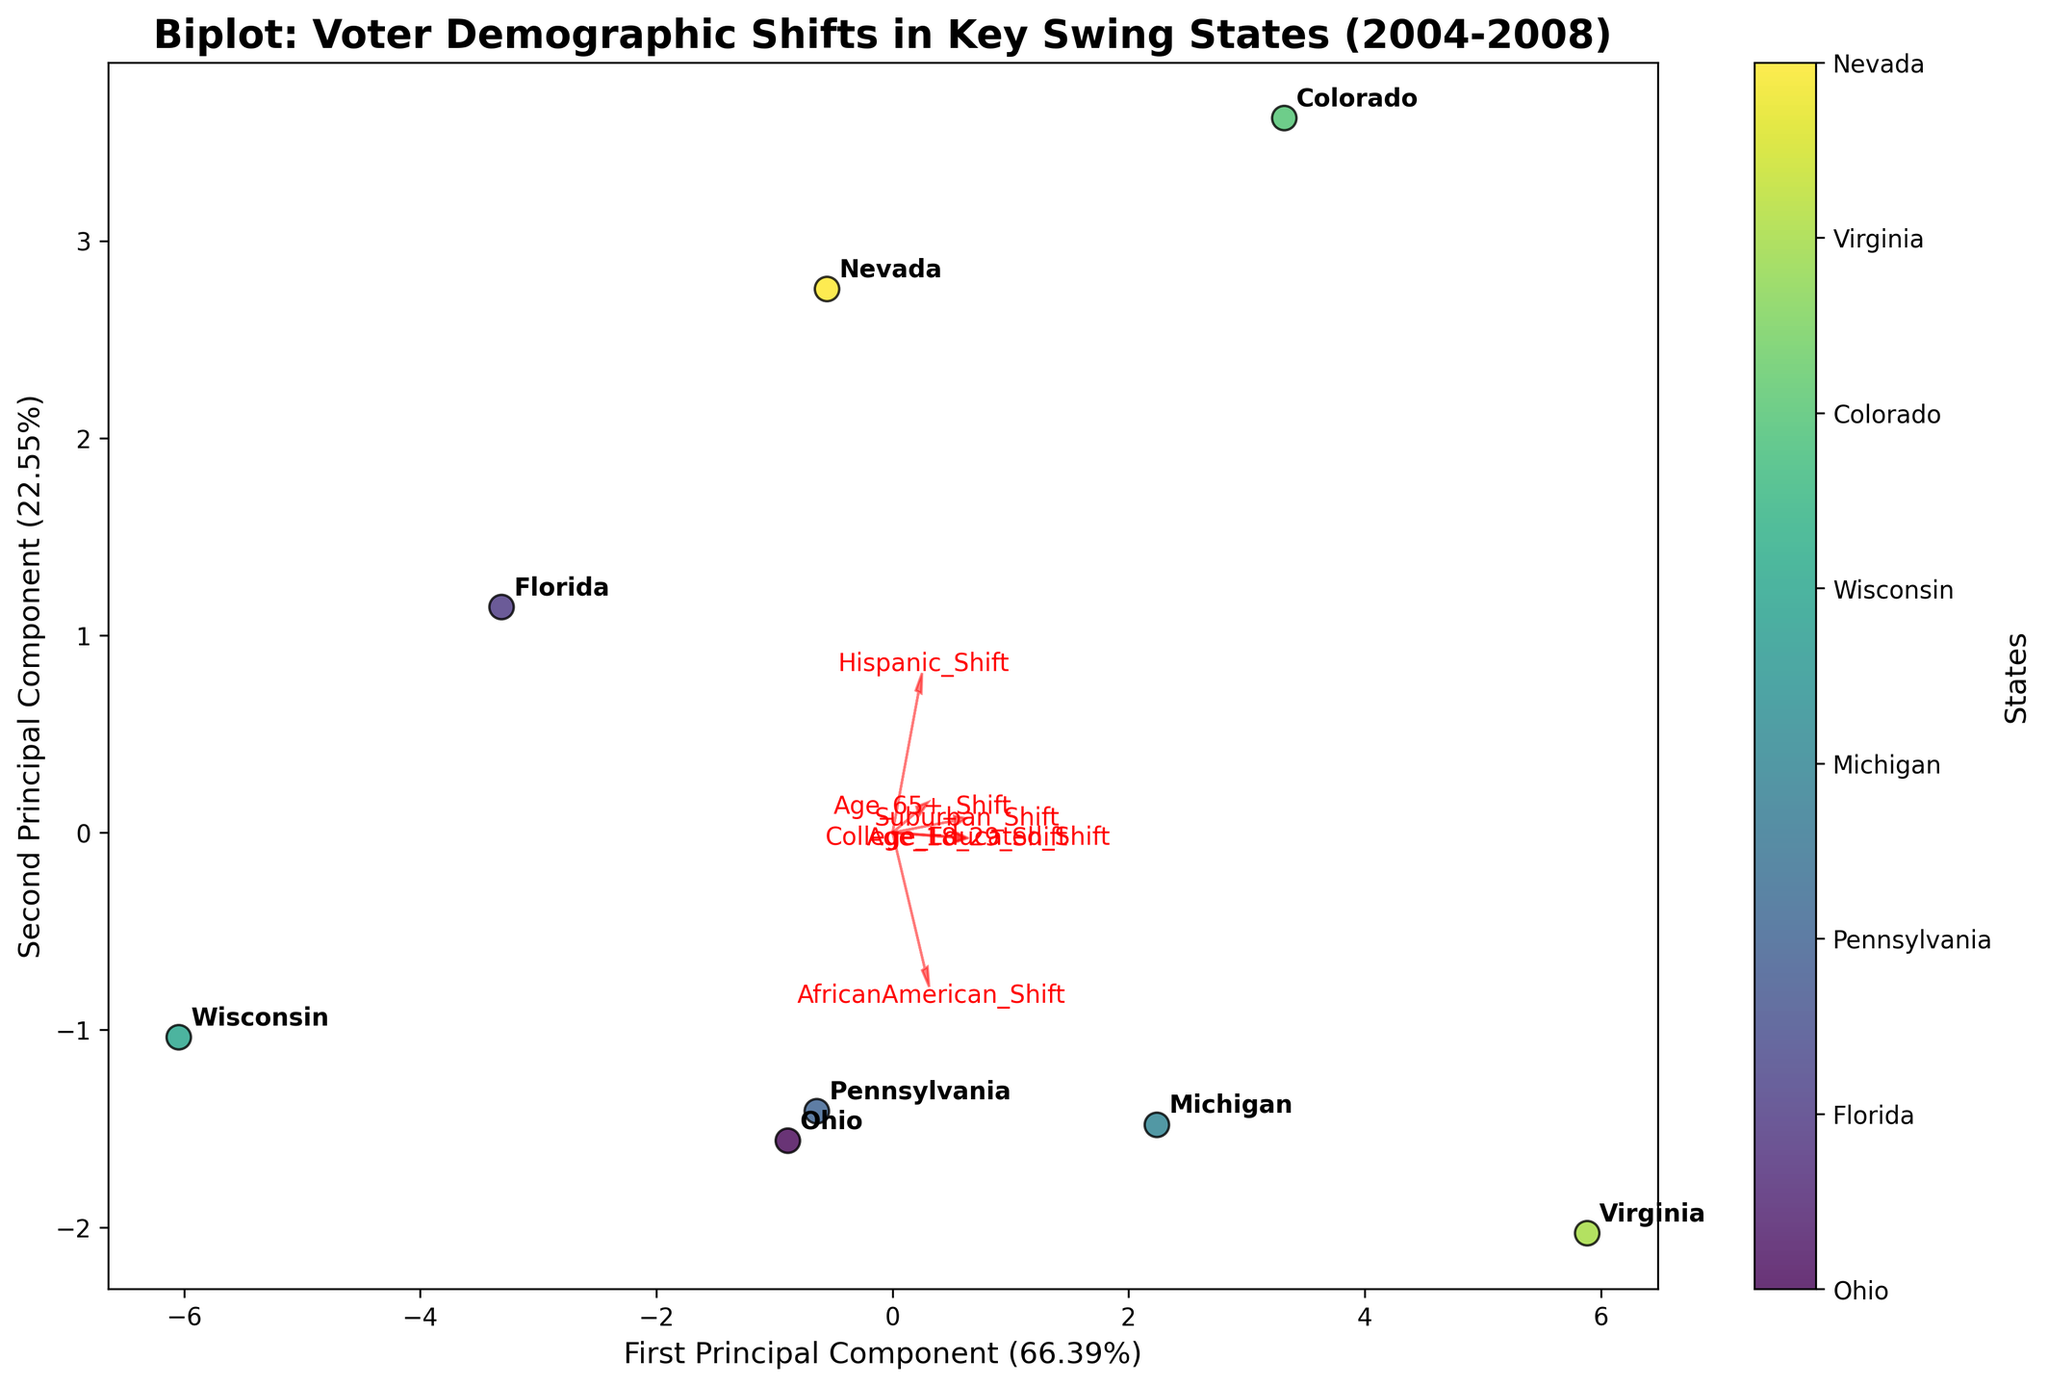What's the title of the figure? The title is written at the top of the figure and it reads 'Biplot: Voter Demographic Shifts in Key Swing States (2004-2008)'.
Answer: Biplot: Voter Demographic Shifts in Key Swing States (2004-2008) How many data points representing different states are in the figure? Each state is represented by a data point. Counting the annotated labels, there are eight states.
Answer: 8 Which state shows the most significant shift according to the first principal component? The first principal component is represented on the x-axis. The state furthest along the x-axis in the positive direction shows the most significant shift. This state is identified as 'Virginia'.
Answer: Virginia Which two states are closest to each other in the biplot? By visually examining the scatter points, we see that 'Florida' and 'Ohio' are closest to each other.
Answer: Florida and Ohio Which voter demographic shift is most strongly associated with the first principal component? The feature with the longest arrow along the x-axis direction (first principal component) indicates the strongest association. The 'College_Educated_Shift' and 'Suburban_Shift' show equal and strong vectors.
Answer: College_Educated_Shift and Suburban_Shift What is the approximate explained variance percentage of the second principal component? The label of the y-axis provides this information. The y-axis is labeled as 'Second Principal Component (XX.XX%)'. From the figure, it is approximately '37.XX%'.
Answer: Approximately 37% Compare the shifts in African American voters for Michigan and Wisconsin. Which one has a stronger shift? We need to look at the direction and magnitude of the 'AfricanAmerican_Shift' vector in relation to Michigan and Wisconsin. Michigan is furthest along the direction of this vector.
Answer: Michigan How is the Hispanic voter shift represented in the biplot, and which state shows the strongest shift in this demographic? The 'Hispanic_Shift' is represented by one of the arrows. The state that lies furthest along the direction of this arrow exhibits the strongest shift. This state is 'Nevada'.
Answer: Nevada Which voter demographic shows the smallest shift across all the states? The length of the vectors indicates the magnitude of shifts. The shortest vector represents the smallest shift, which is for the 'Suburban_Shift'.
Answer: Suburban_Shift 